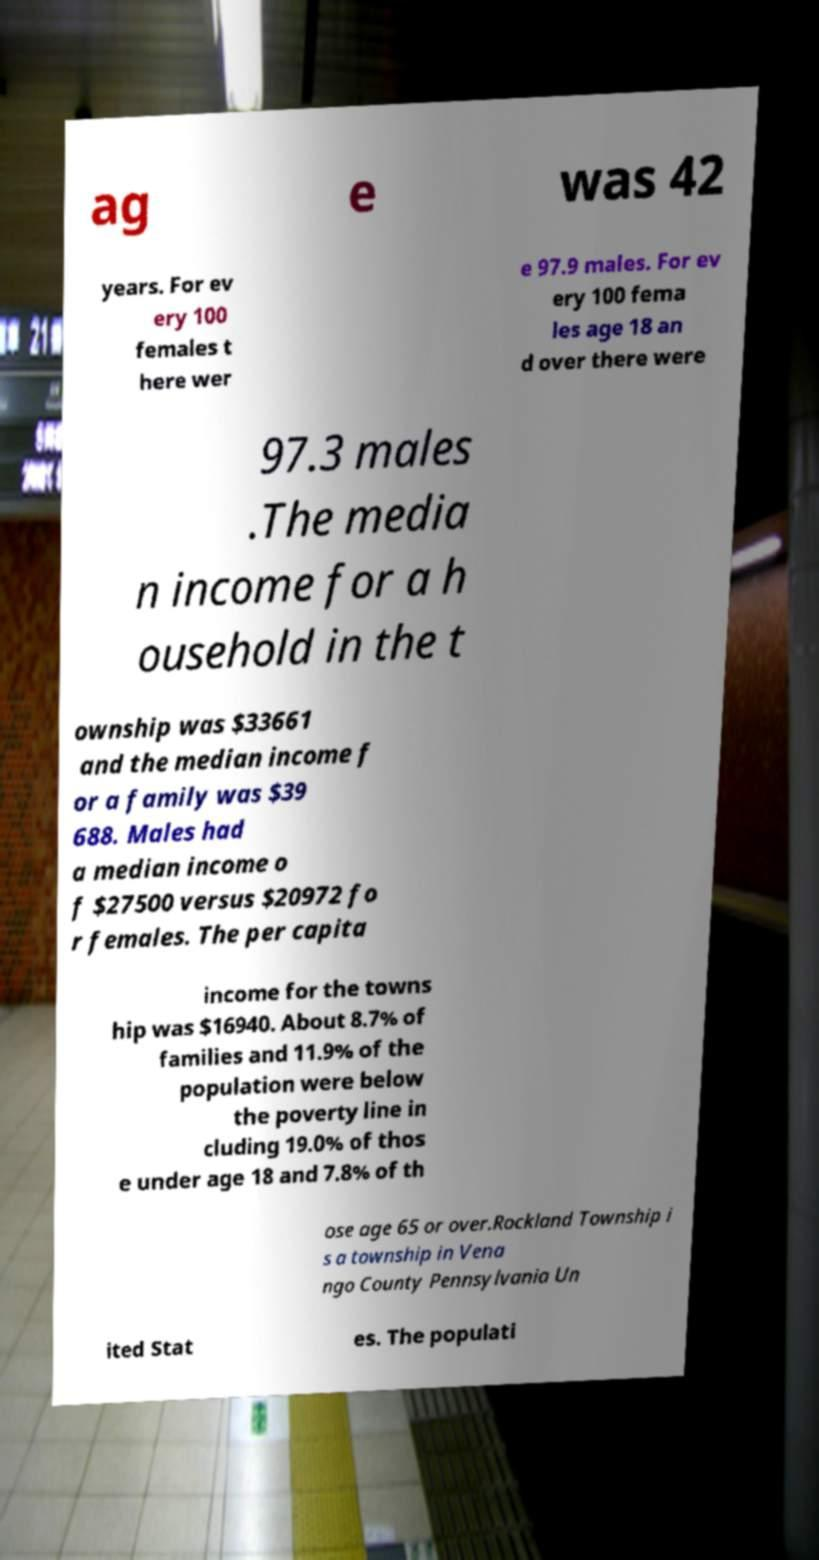For documentation purposes, I need the text within this image transcribed. Could you provide that? ag e was 42 years. For ev ery 100 females t here wer e 97.9 males. For ev ery 100 fema les age 18 an d over there were 97.3 males .The media n income for a h ousehold in the t ownship was $33661 and the median income f or a family was $39 688. Males had a median income o f $27500 versus $20972 fo r females. The per capita income for the towns hip was $16940. About 8.7% of families and 11.9% of the population were below the poverty line in cluding 19.0% of thos e under age 18 and 7.8% of th ose age 65 or over.Rockland Township i s a township in Vena ngo County Pennsylvania Un ited Stat es. The populati 